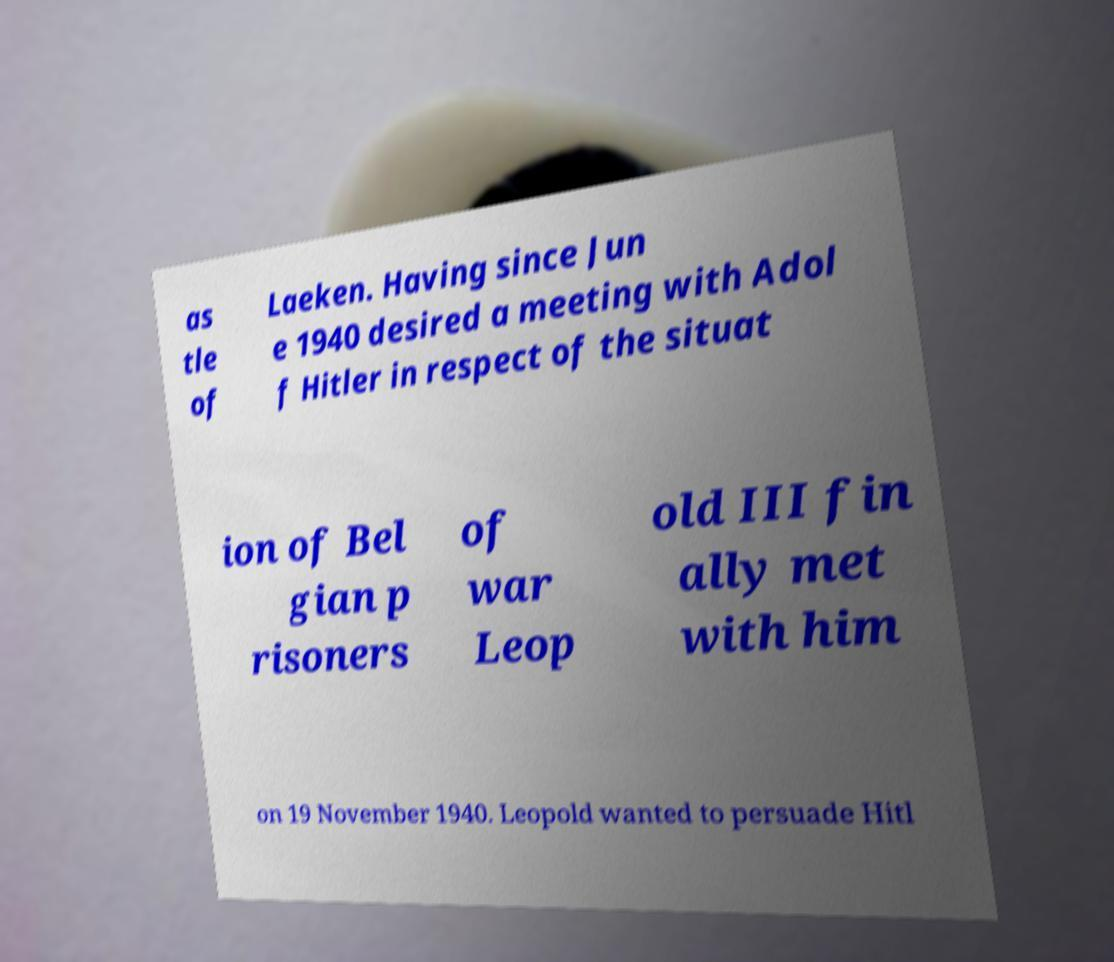Can you accurately transcribe the text from the provided image for me? as tle of Laeken. Having since Jun e 1940 desired a meeting with Adol f Hitler in respect of the situat ion of Bel gian p risoners of war Leop old III fin ally met with him on 19 November 1940. Leopold wanted to persuade Hitl 